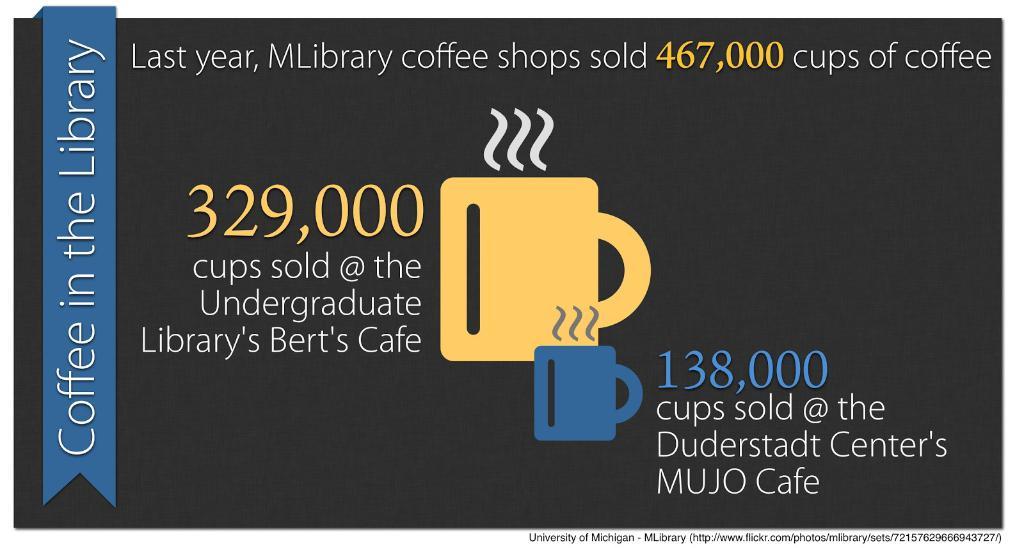How many cups sold at the suderstadt center's mujo cafe?
Your response must be concise. 138,000. How many cups were sold?
Ensure brevity in your answer.  329,000. 